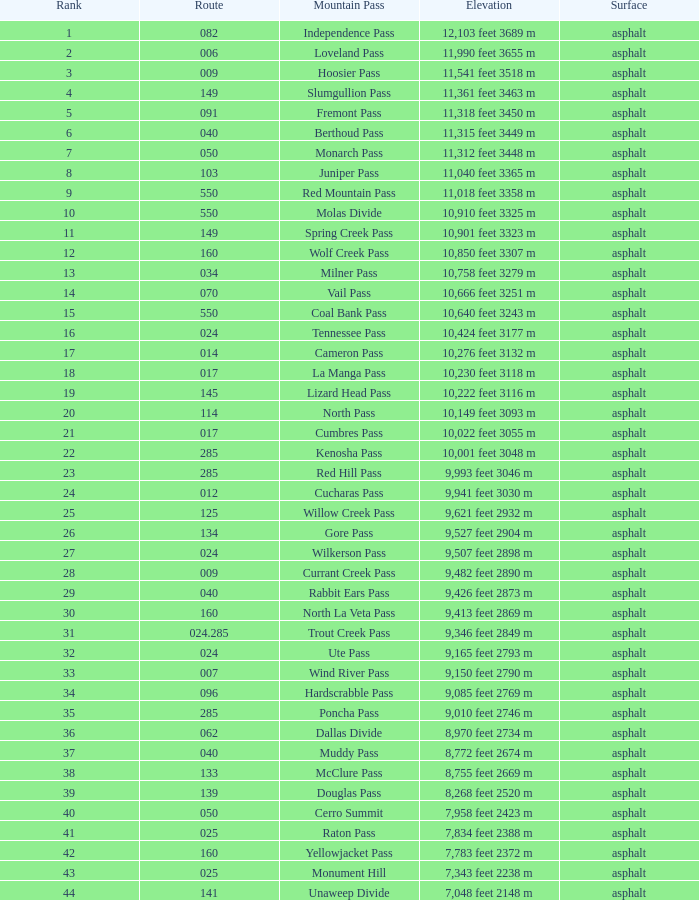What is the Surface of the Route less than 7? Asphalt. 